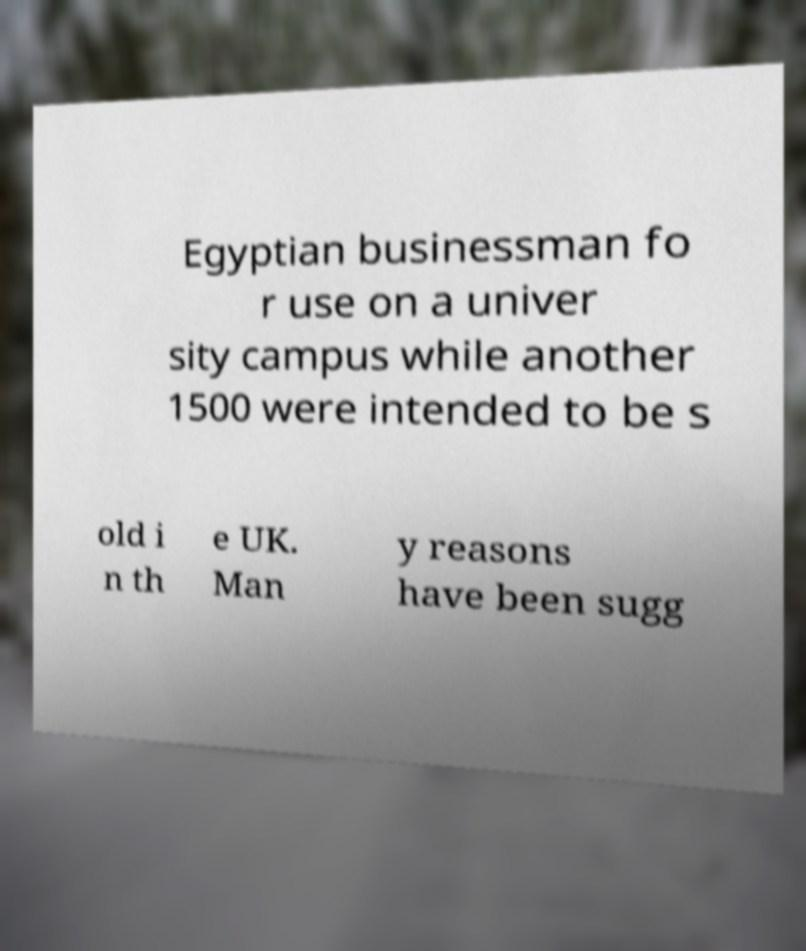I need the written content from this picture converted into text. Can you do that? Egyptian businessman fo r use on a univer sity campus while another 1500 were intended to be s old i n th e UK. Man y reasons have been sugg 